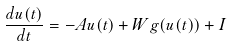<formula> <loc_0><loc_0><loc_500><loc_500>\frac { d u ( t ) } { d t } = - A u ( t ) + W g ( u ( t ) ) + I</formula> 